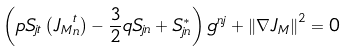<formula> <loc_0><loc_0><loc_500><loc_500>\left ( p S _ { j t } \left ( { J _ { M } } _ { n } ^ { t } \right ) - \frac { 3 } { 2 } q S _ { j n } + S _ { j n } ^ { \ast } \right ) g ^ { n j } + { \left \| \nabla J _ { M } \right \| } ^ { 2 } = 0</formula> 